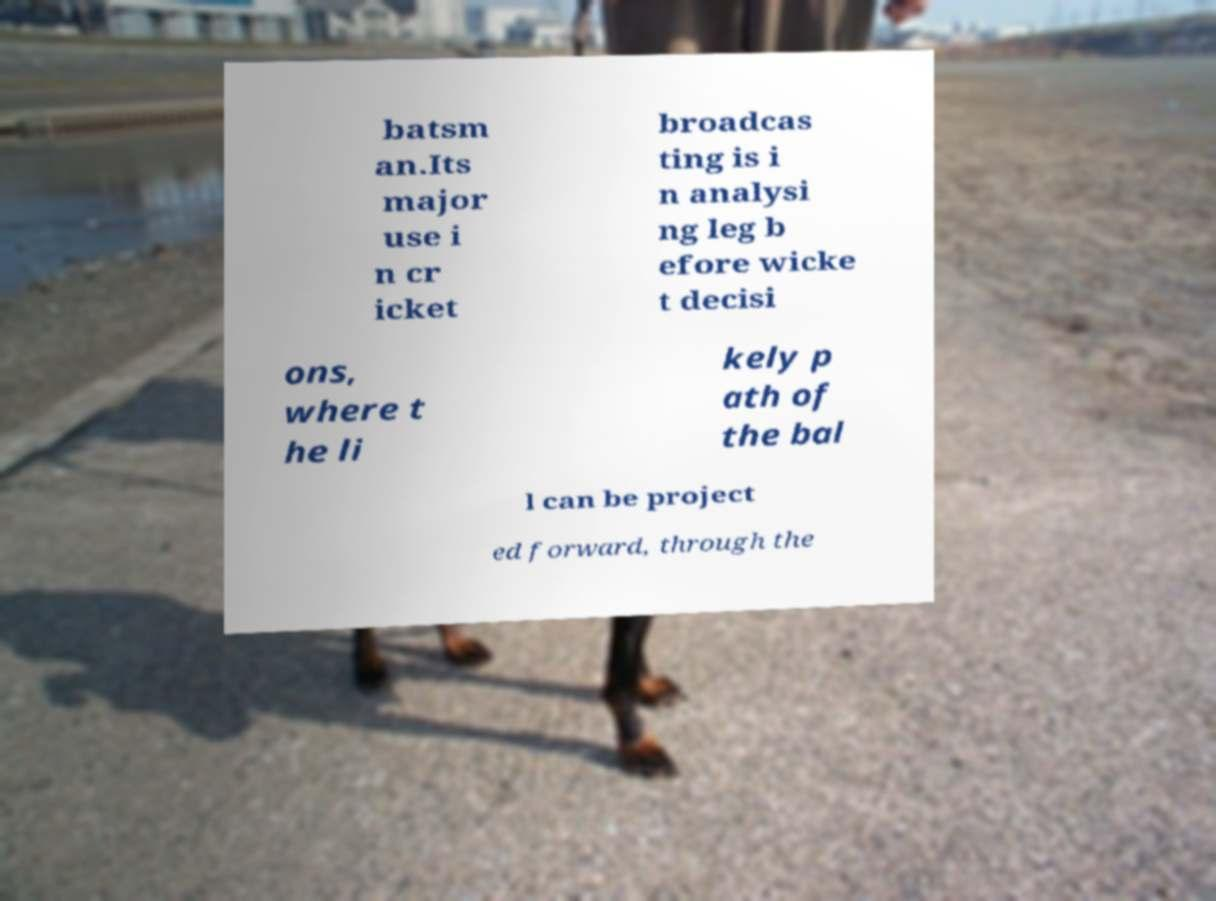There's text embedded in this image that I need extracted. Can you transcribe it verbatim? batsm an.Its major use i n cr icket broadcas ting is i n analysi ng leg b efore wicke t decisi ons, where t he li kely p ath of the bal l can be project ed forward, through the 